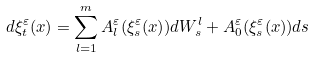<formula> <loc_0><loc_0><loc_500><loc_500>d \xi _ { t } ^ { \varepsilon } ( x ) = \sum _ { l = 1 } ^ { m } A _ { l } ^ { \varepsilon } ( \xi _ { s } ^ { \varepsilon } ( x ) ) d W _ { s } ^ { l } + A _ { 0 } ^ { \varepsilon } ( \xi _ { s } ^ { \varepsilon } ( x ) ) d s</formula> 